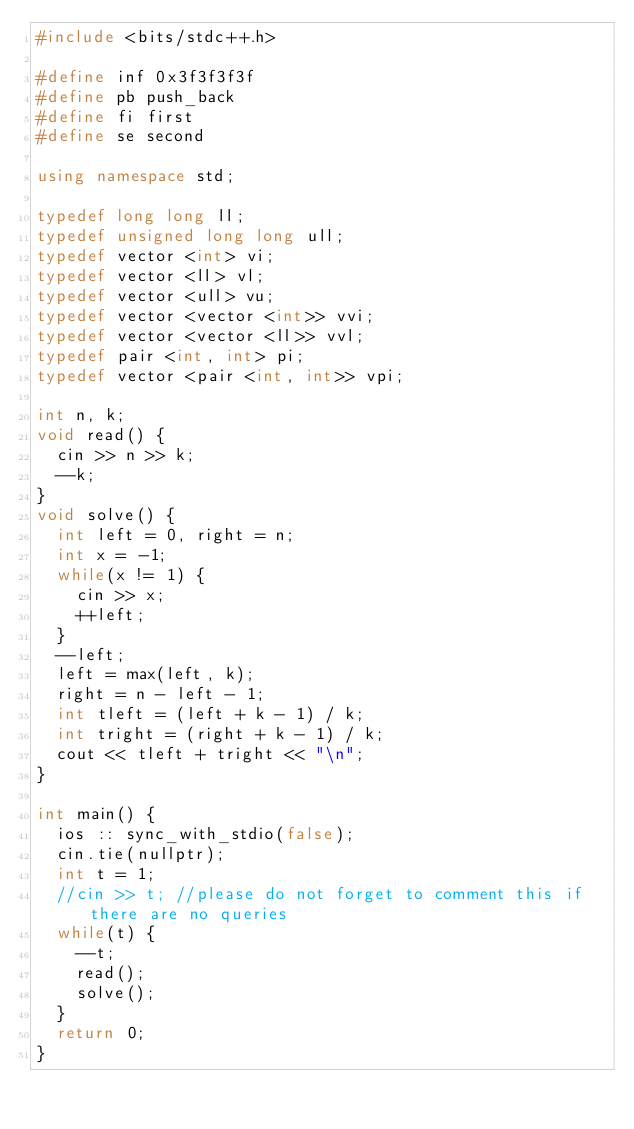<code> <loc_0><loc_0><loc_500><loc_500><_C++_>#include <bits/stdc++.h>
 
#define inf 0x3f3f3f3f
#define pb push_back
#define fi first
#define se second
 
using namespace std;
 
typedef long long ll;
typedef unsigned long long ull;
typedef vector <int> vi;
typedef vector <ll> vl;
typedef vector <ull> vu;
typedef vector <vector <int>> vvi;
typedef vector <vector <ll>> vvl;
typedef pair <int, int> pi;
typedef vector <pair <int, int>> vpi;

int n, k;
void read() {
  cin >> n >> k;
  --k;
}
void solve() {
  int left = 0, right = n;
  int x = -1;
  while(x != 1) {
    cin >> x;
    ++left;
  }
  --left;
  left = max(left, k);
  right = n - left - 1;
  int tleft = (left + k - 1) / k;
  int tright = (right + k - 1) / k;
  cout << tleft + tright << "\n";
}

int main() {
  ios :: sync_with_stdio(false);
  cin.tie(nullptr);
  int t = 1;
  //cin >> t; //please do not forget to comment this if there are no queries
  while(t) {
    --t;
    read();
    solve(); 
  }
  return 0;
}
</code> 